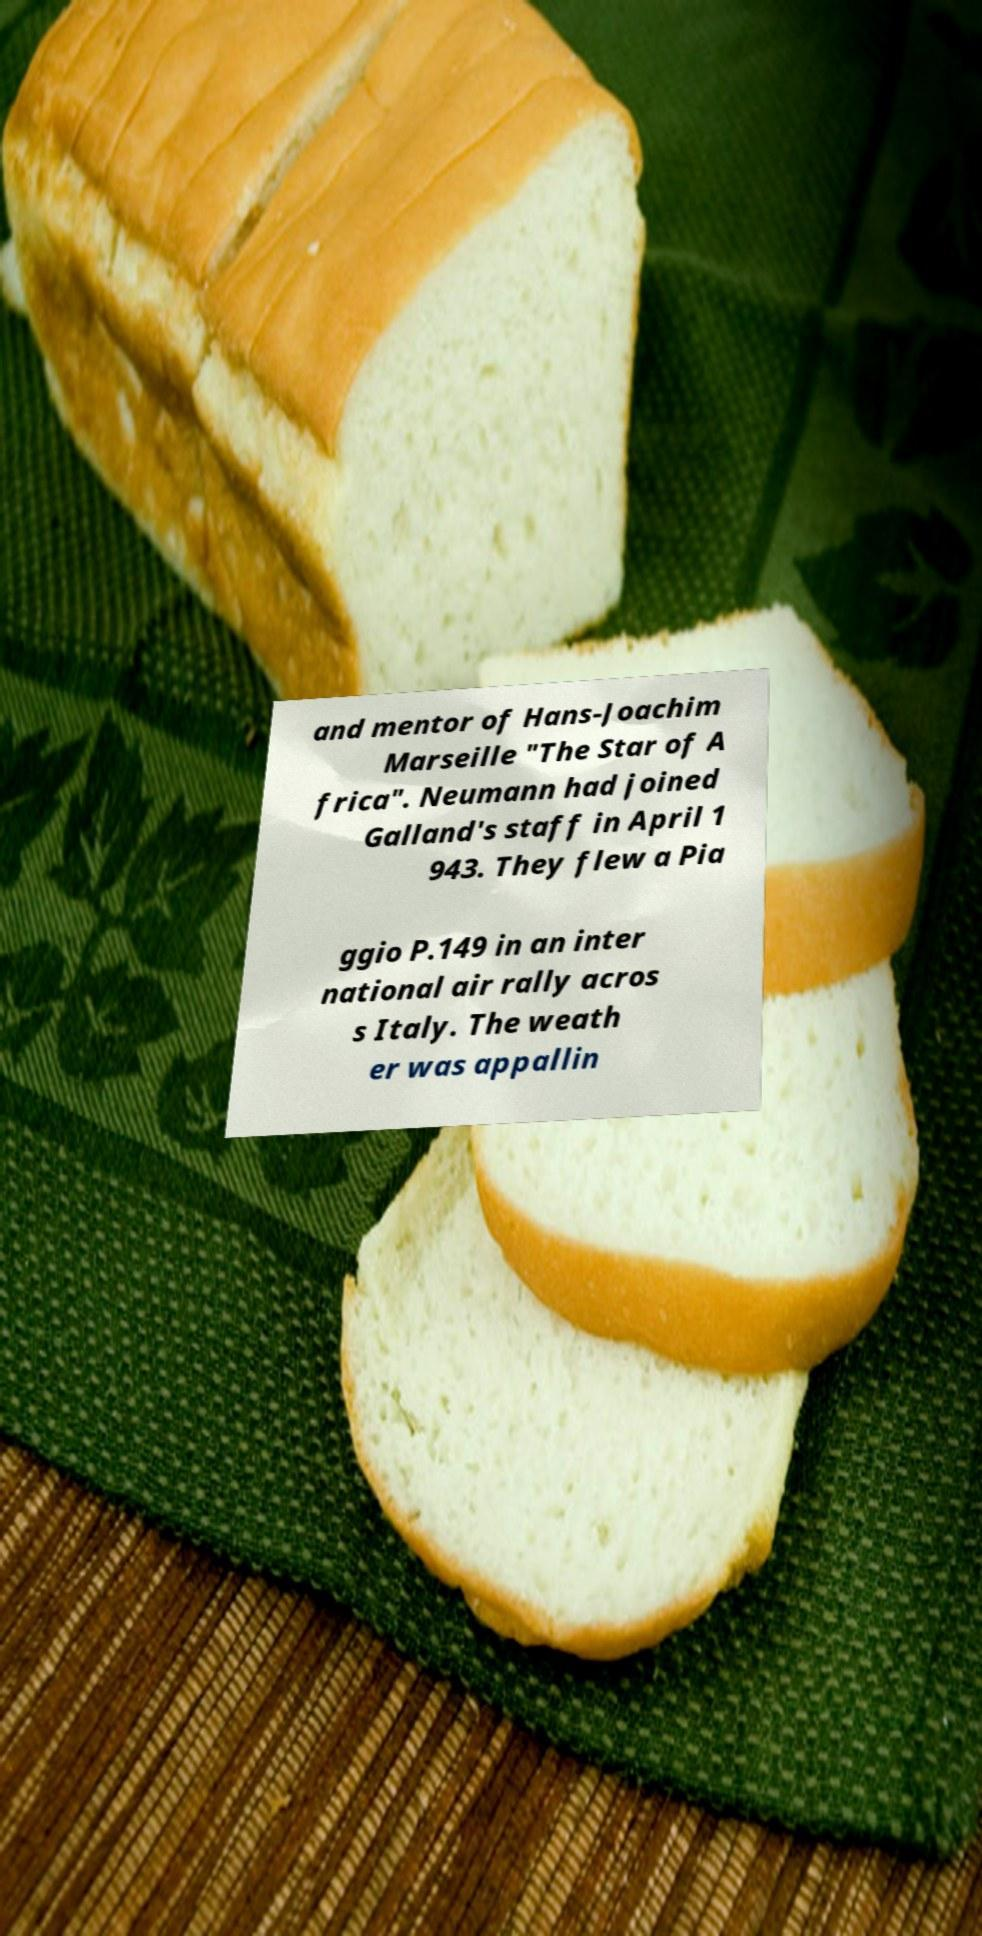Please read and relay the text visible in this image. What does it say? and mentor of Hans-Joachim Marseille "The Star of A frica". Neumann had joined Galland's staff in April 1 943. They flew a Pia ggio P.149 in an inter national air rally acros s Italy. The weath er was appallin 